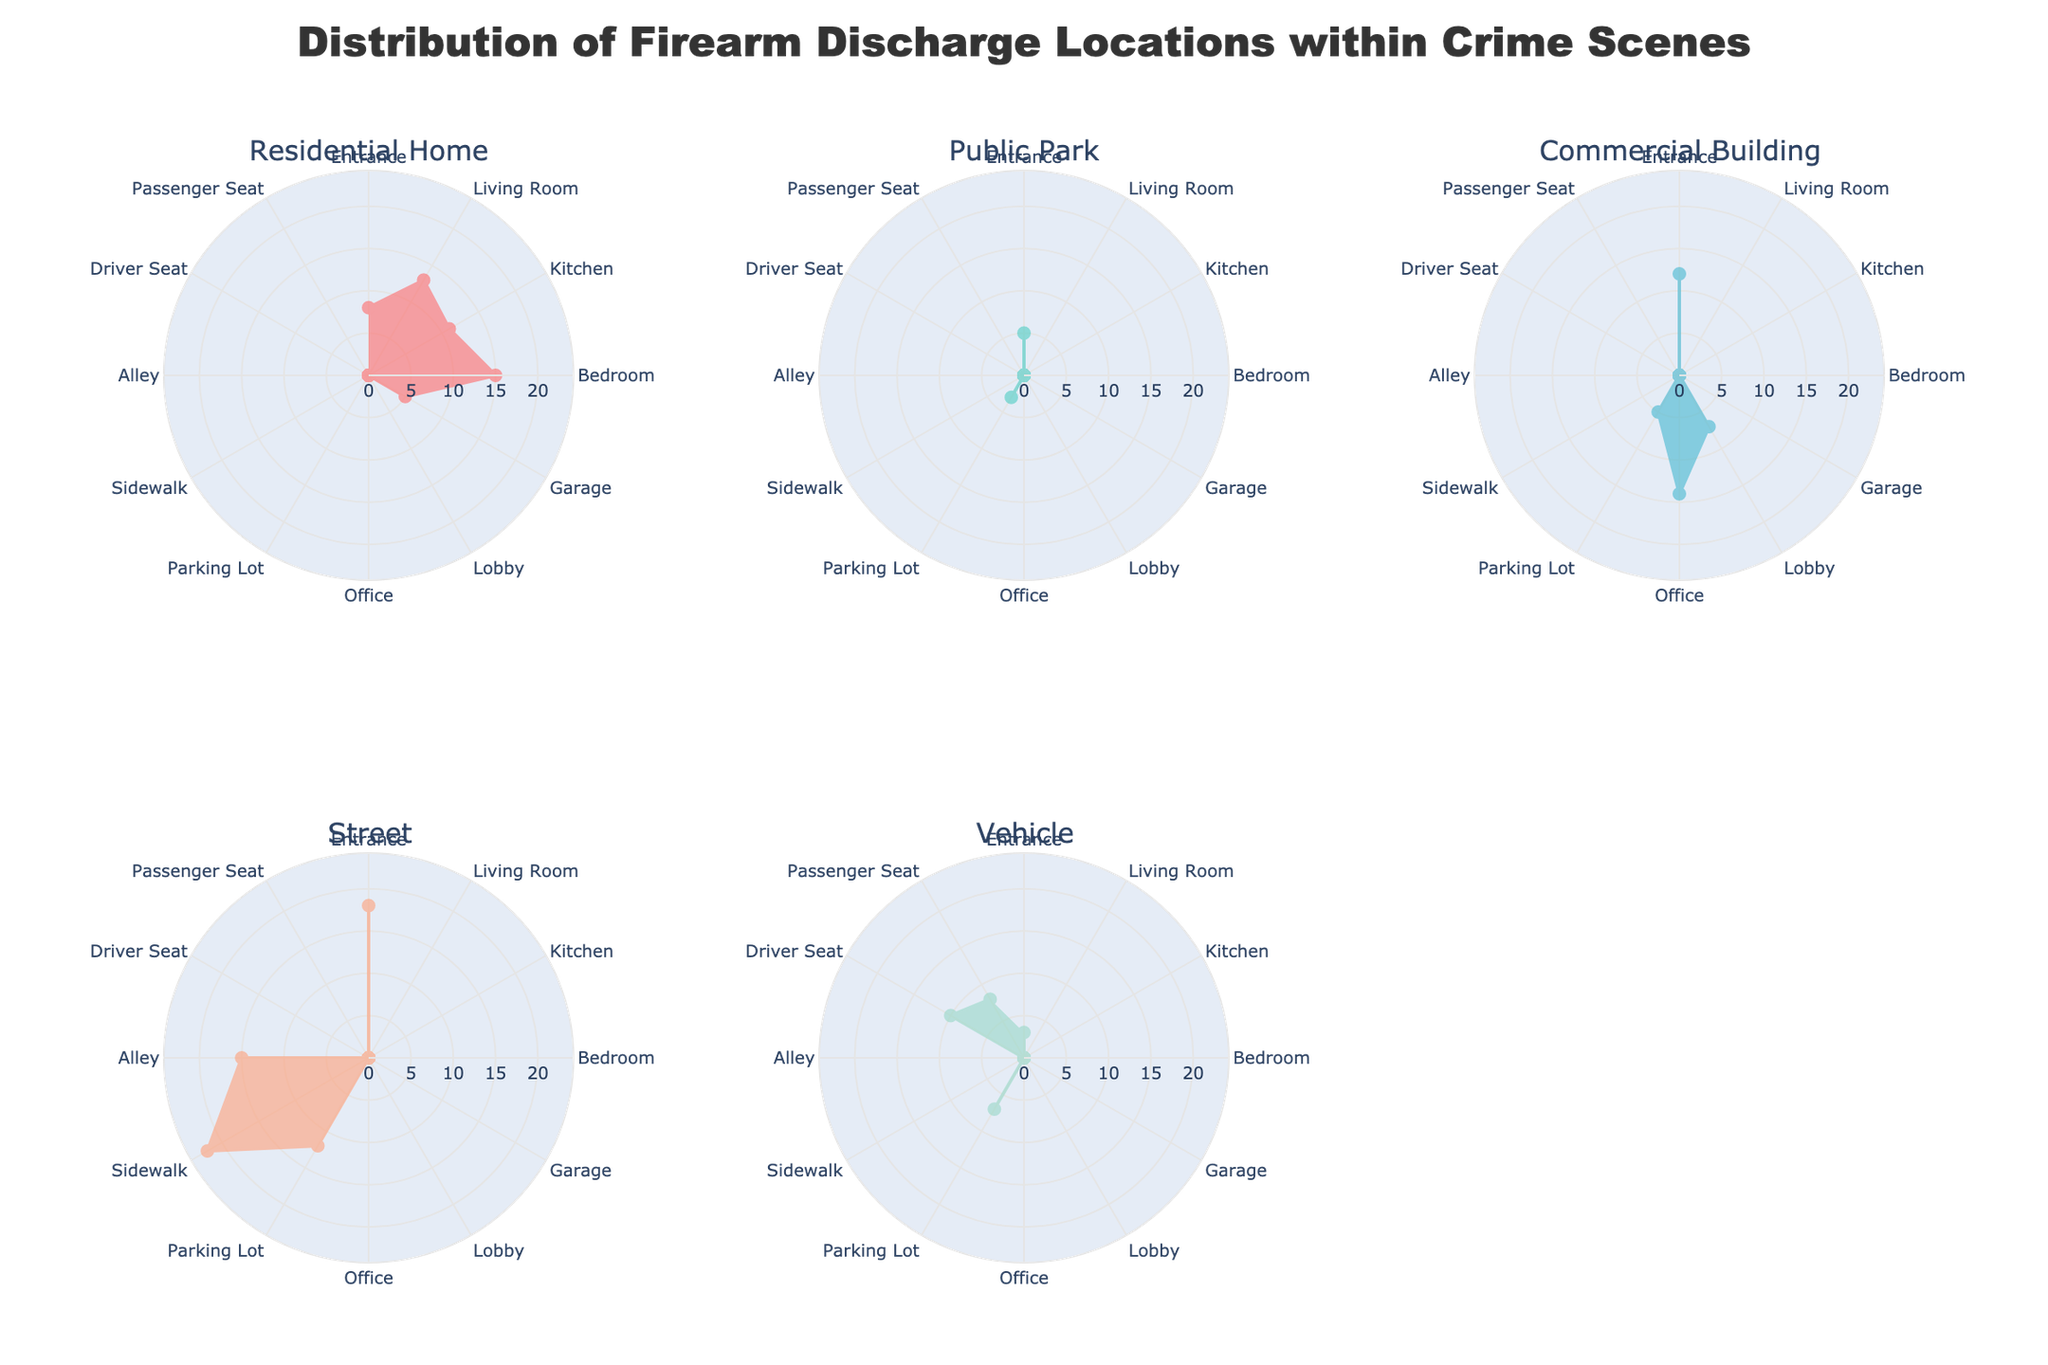Which category has the highest number of firearm discharges in the 'Street' location? In the subplot titled 'Street', observe the radial values for each location. 'Entrance' has the highest number with a value of 18.
Answer: Entrance Which location has firearm discharges present in a Commercial Building but not in a Residential Home? Examine the 'Commercial Building' subplot and identify locations with values greater than zero. Then, check these locations in the 'Residential Home' subplot for any zeros. 'Lobby' and 'Office' show discharges only in a Commercial Building but not in a Residential Home.
Answer: Lobby, Office What is the total number of firearm discharges in the 'Public Park' location? Observe the radar chart for 'Public Park' and sum the values of all locations within this category. The total is 5 (Entrance) + 0 (Living Room) + 0 (Kitchen) + 0 (Bedroom) + 0 (Garage) + 3 (Parking Lot) = 8.
Answer: 8 In which location is firearm discharge exclusively recorded in the 'Vehicle' category? Identify locations with values greater than zero in the 'Vehicle' subplot and not present in any other subplots. Both 'Driver Seat' and 'Passenger Seat' fit this criterion.
Answer: Driver Seat, Passenger Seat Compare the number of firearm discharges in the 'Bedroom' in Residential Home and 'Office' in a Commercial Building. Which is higher? Locate values for 'Bedroom' in the 'Residential Home' subplot and 'Office' in the 'Commercial Building' subplot. 'Bedroom' has a value of 15, while 'Office' has 14. Thus, 'Bedroom' has more discharges.
Answer: Bedroom What is the average number of firearm discharges across all locations in the 'Vehicle' category? Sum the values for all locations in the 'Vehicle' subplot and divide by the number of locations. The total is 3 + 0 + 0 + 0 + 0 + 7 + 10 + 8 = 28, and there are 5 contributing locations: 28 / 5 = 5.6.
Answer: 5.6 Which location has the highest frequency of firearm discharges overall across all categories? To determine this, visually inspect each subplot. 'Sidewalk' in the 'Street' subplot shows the highest frequency with a value of 22.
Answer: Sidewalk How many locations have at least one recorded discharge in the 'Commercial Building' category? Count the locations with a non-zero value in the 'Commercial Building' subplot. There are 4 such locations: Entrance (12), Lobby (7), Office (14), and Parking Lot (5).
Answer: 4 